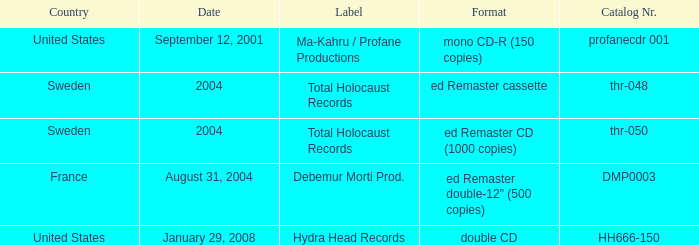What country is the Debemur Morti prod. label from? France. 